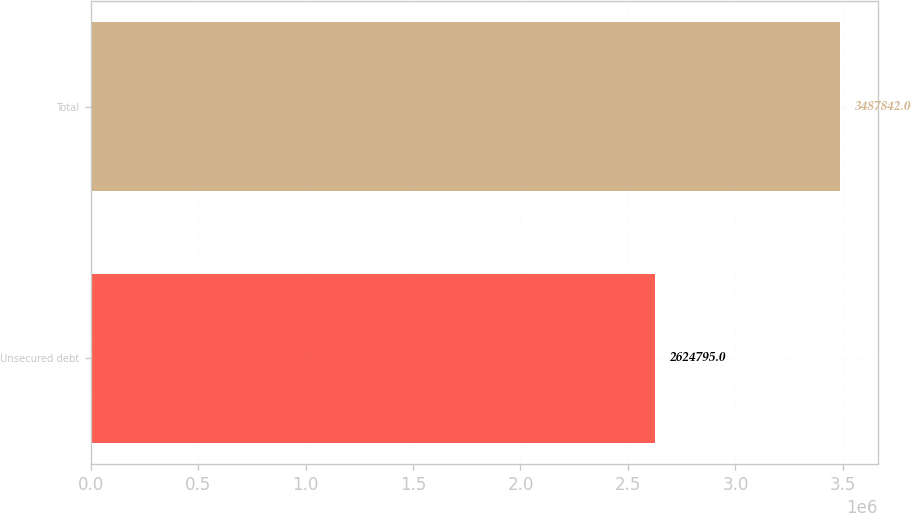Convert chart to OTSL. <chart><loc_0><loc_0><loc_500><loc_500><bar_chart><fcel>Unsecured debt<fcel>Total<nl><fcel>2.6248e+06<fcel>3.48784e+06<nl></chart> 